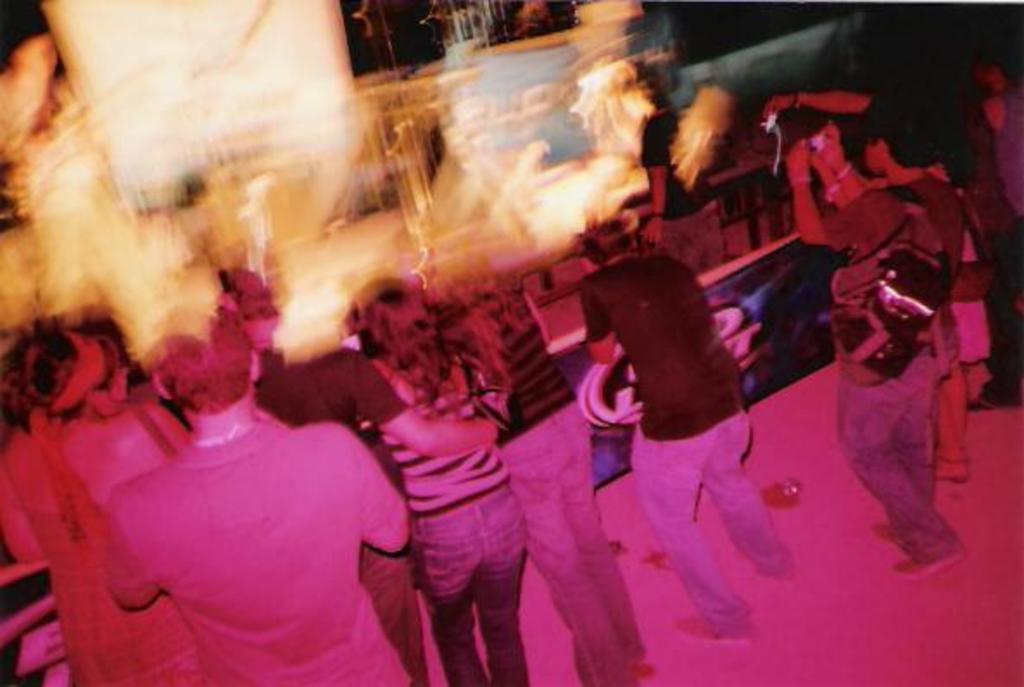How would you summarize this image in a sentence or two? Here in this picture we can see number of people standing on the floor over there and the persons on the right side are clicking pictures with bags on them and in their front we can see some performance done by some people over there. 